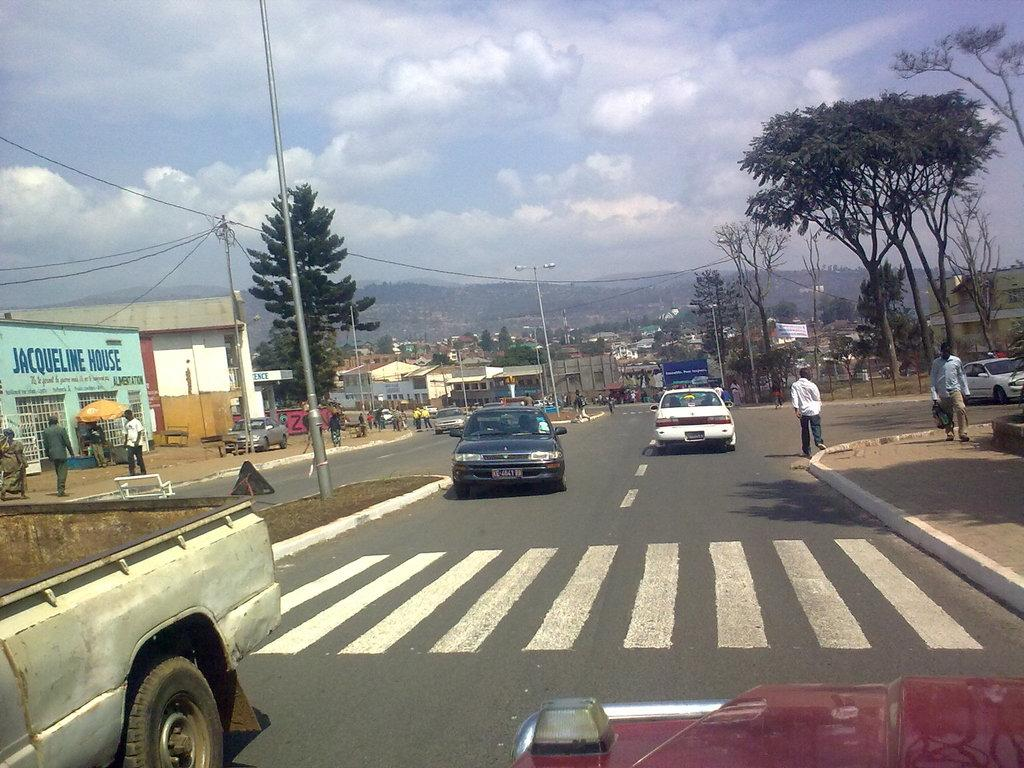What type of vehicles can be seen on the road in the image? There are motor vehicles on the road in the image. What are the people on the road doing? People are standing on the road in the image. What type of establishments can be seen in the image? There are stores in the image. What type of structures can be seen in the image? There are buildings in the image. What type of street furniture is visible in the image? Street poles and street lights are present in the image. What type of infrastructure is visible in the image? Cables are visible in the image. What type of natural elements are present in the image? Trees are present in the image. What is visible in the sky in the image? The sky is visible in the image, and clouds are visible in the sky. Where is the marble located in the image? There is no marble present in the image. What is the grandfather doing in the image? There is no grandfather present in the image. What type of maid is visible in the image? There is no maid present in the image. 